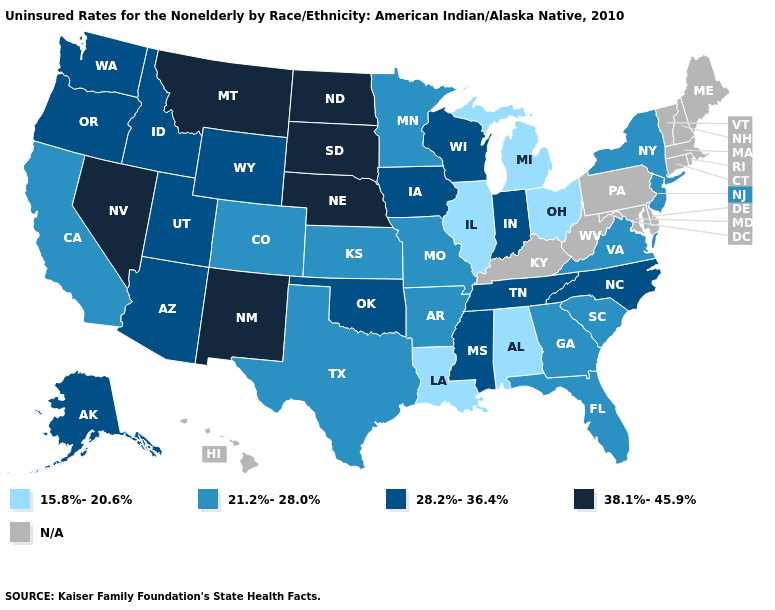Which states hav the highest value in the Northeast?
Answer briefly. New Jersey, New York. Name the states that have a value in the range 15.8%-20.6%?
Quick response, please. Alabama, Illinois, Louisiana, Michigan, Ohio. Does Wyoming have the highest value in the USA?
Be succinct. No. What is the highest value in the South ?
Write a very short answer. 28.2%-36.4%. Among the states that border Pennsylvania , which have the highest value?
Short answer required. New Jersey, New York. Is the legend a continuous bar?
Concise answer only. No. Name the states that have a value in the range 38.1%-45.9%?
Be succinct. Montana, Nebraska, Nevada, New Mexico, North Dakota, South Dakota. Which states have the lowest value in the Northeast?
Write a very short answer. New Jersey, New York. Name the states that have a value in the range 28.2%-36.4%?
Concise answer only. Alaska, Arizona, Idaho, Indiana, Iowa, Mississippi, North Carolina, Oklahoma, Oregon, Tennessee, Utah, Washington, Wisconsin, Wyoming. What is the value of Virginia?
Be succinct. 21.2%-28.0%. What is the lowest value in states that border Kansas?
Answer briefly. 21.2%-28.0%. Name the states that have a value in the range N/A?
Answer briefly. Connecticut, Delaware, Hawaii, Kentucky, Maine, Maryland, Massachusetts, New Hampshire, Pennsylvania, Rhode Island, Vermont, West Virginia. Among the states that border West Virginia , does Virginia have the highest value?
Write a very short answer. Yes. What is the value of Virginia?
Short answer required. 21.2%-28.0%. Does the first symbol in the legend represent the smallest category?
Give a very brief answer. Yes. 